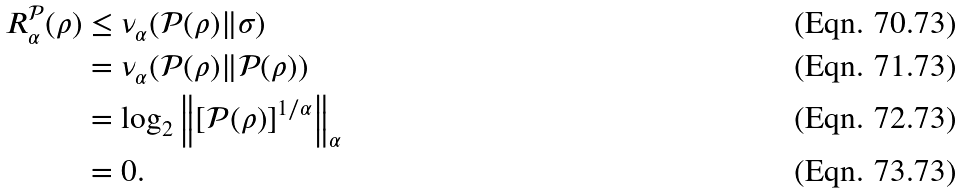<formula> <loc_0><loc_0><loc_500><loc_500>R _ { \alpha } ^ { \mathcal { P } } ( \rho ) & \leq \nu _ { \alpha } ( \mathcal { P } ( \rho ) \| \sigma ) \\ & = \nu _ { \alpha } ( \mathcal { P } ( \rho ) \| \mathcal { P } ( \rho ) ) \\ & = \log _ { 2 } \left \| \left [ \mathcal { P } ( \rho ) \right ] ^ { 1 / \alpha } \right \| _ { \alpha } \\ & = 0 .</formula> 